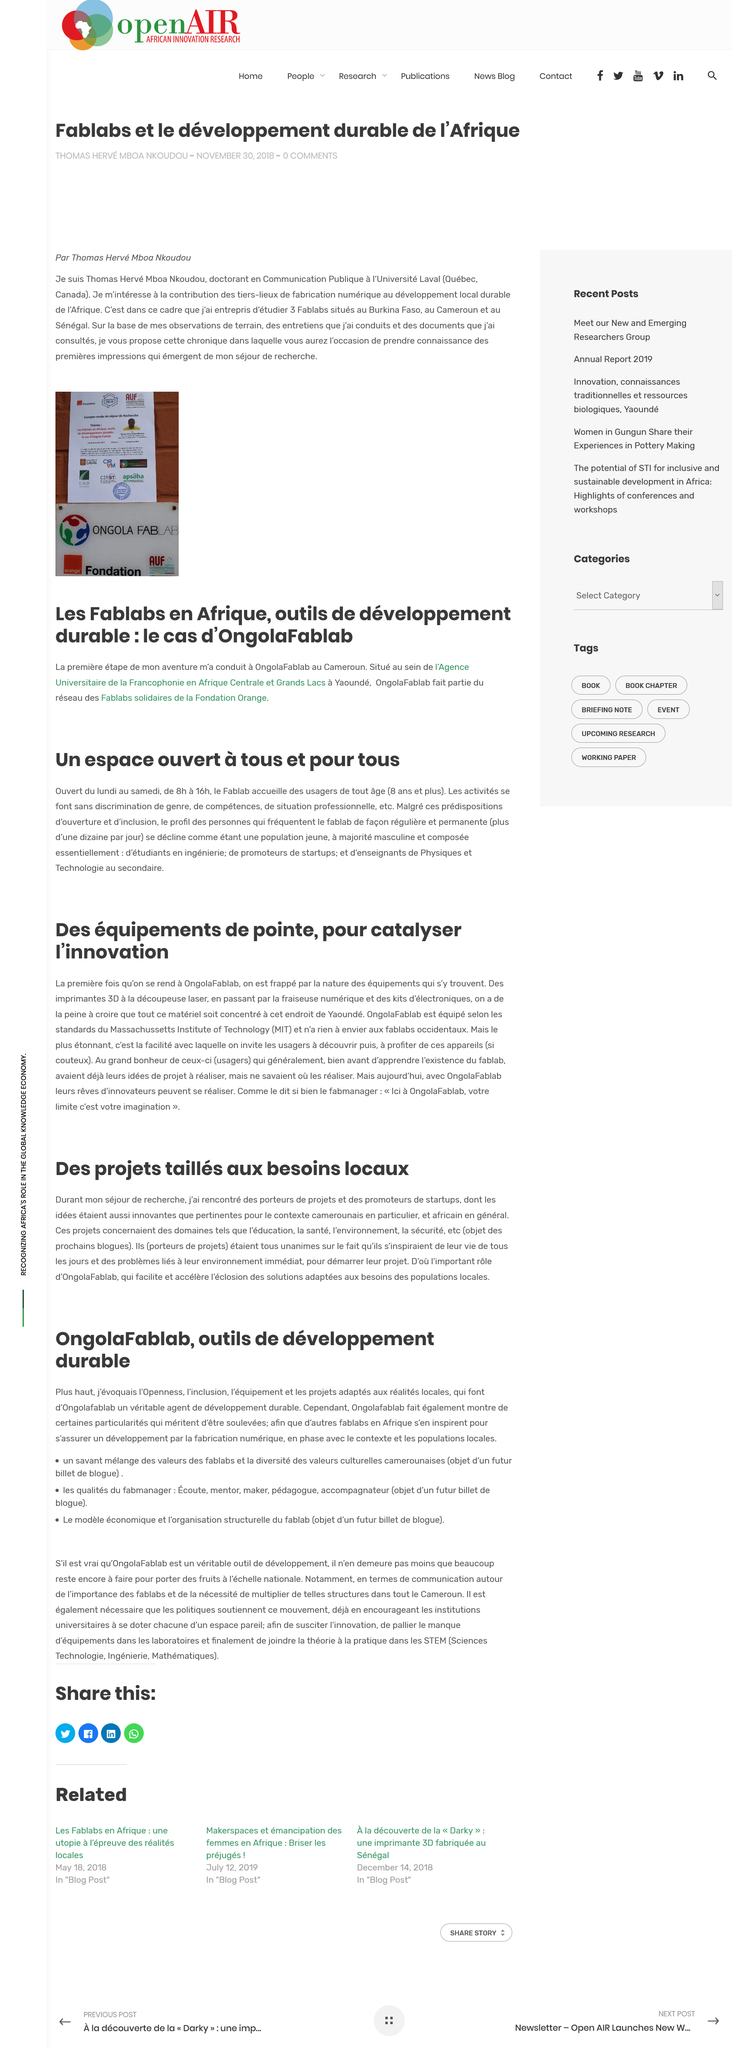Specify some key components in this picture. Thomas Hervé Mbo Nkoudou wrote the article "Fablabs et le développement durable de l'Afrique. Thomas Hervé Mboa Nkoudou is a doctoral candidate in Communication at the University of Laval. The article is not written in English. The title of this article is 'OngolaFablab, Sustainable Development Tools.' Our projects focus on education, health, environment, and security domains. 